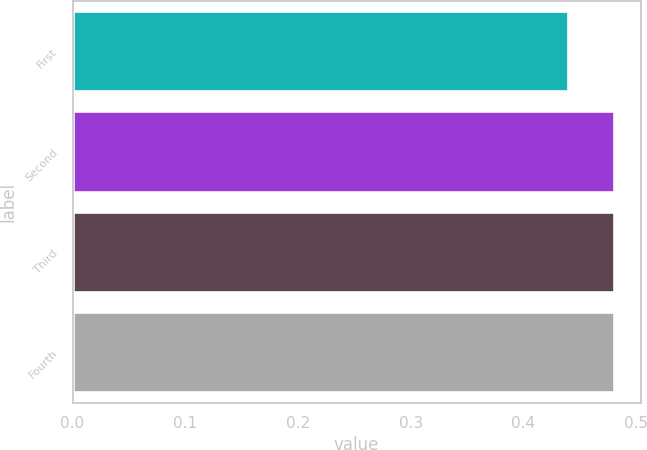Convert chart. <chart><loc_0><loc_0><loc_500><loc_500><bar_chart><fcel>First<fcel>Second<fcel>Third<fcel>Fourth<nl><fcel>0.44<fcel>0.48<fcel>0.48<fcel>0.48<nl></chart> 